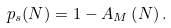Convert formula to latex. <formula><loc_0><loc_0><loc_500><loc_500>p _ { s } ( N ) = 1 - A _ { M } \left ( N \right ) .</formula> 